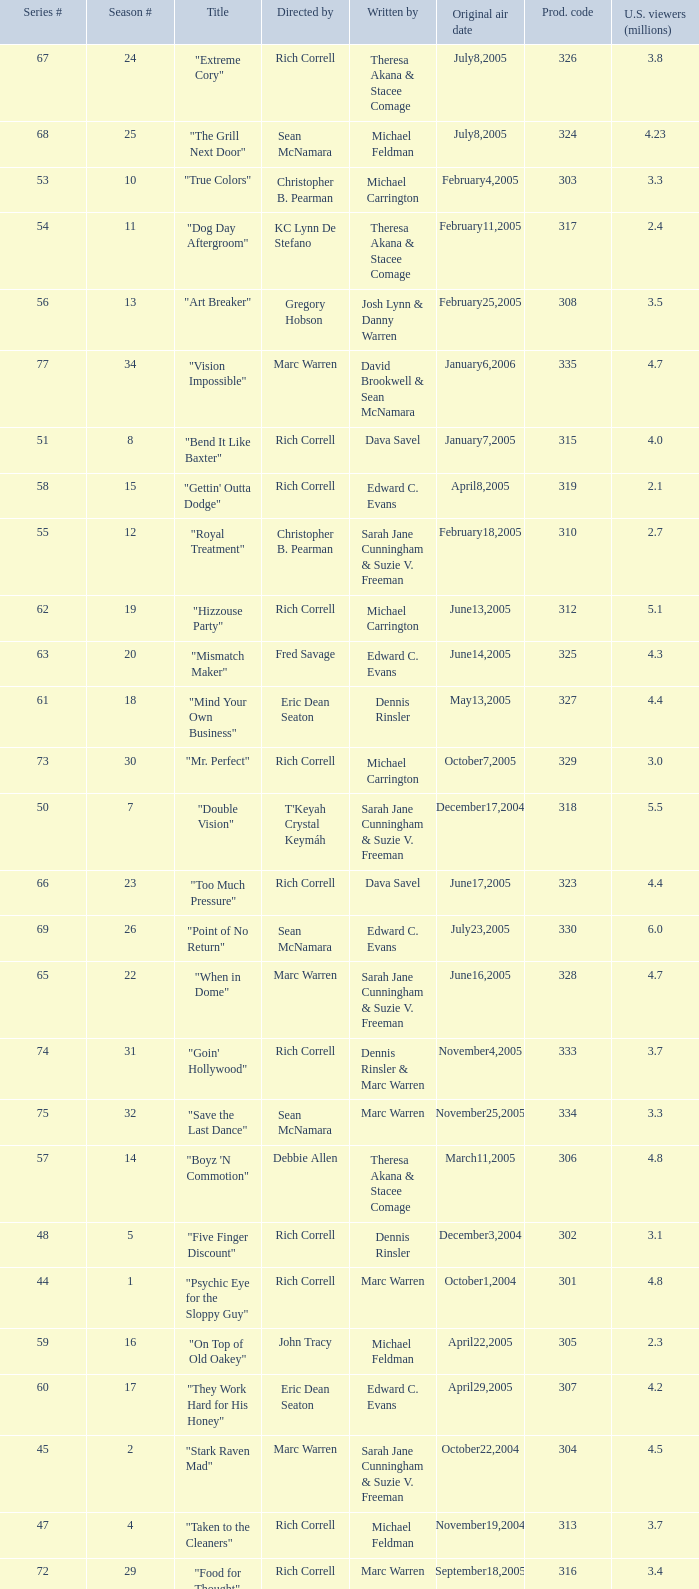What is the title of the episode directed by Rich Correll and written by Dennis Rinsler? "Five Finger Discount". 